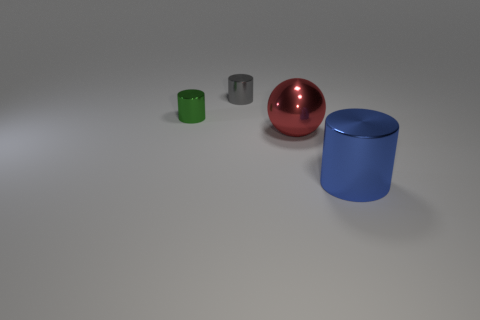Add 3 metallic spheres. How many objects exist? 7 Subtract all cylinders. How many objects are left? 1 Add 2 tiny gray shiny cubes. How many tiny gray shiny cubes exist? 2 Subtract 0 cyan spheres. How many objects are left? 4 Subtract all blue shiny cylinders. Subtract all tiny gray metallic cylinders. How many objects are left? 2 Add 1 big objects. How many big objects are left? 3 